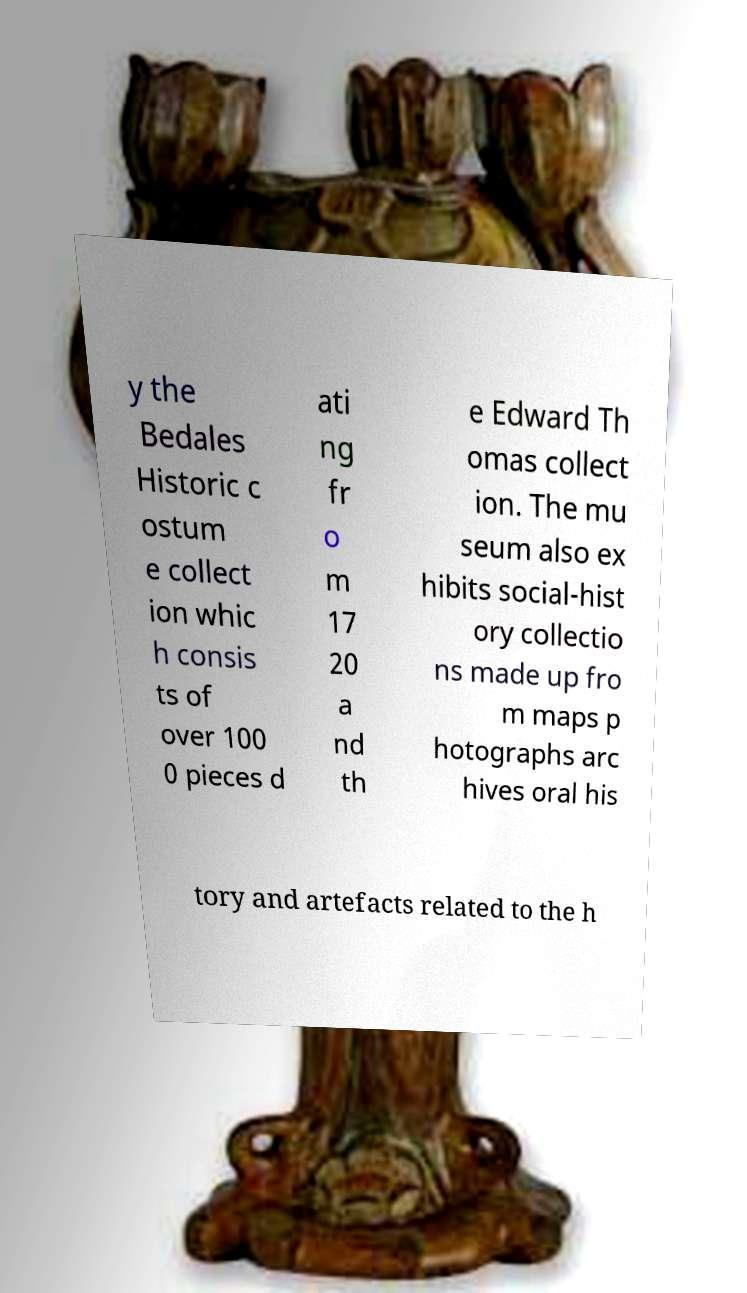For documentation purposes, I need the text within this image transcribed. Could you provide that? y the Bedales Historic c ostum e collect ion whic h consis ts of over 100 0 pieces d ati ng fr o m 17 20 a nd th e Edward Th omas collect ion. The mu seum also ex hibits social-hist ory collectio ns made up fro m maps p hotographs arc hives oral his tory and artefacts related to the h 